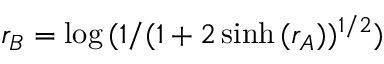<formula> <loc_0><loc_0><loc_500><loc_500>r _ { B } = \log { ( 1 / ( 1 + 2 \sinh { ( r _ { A } ) } ) ^ { 1 / 2 } ) }</formula> 